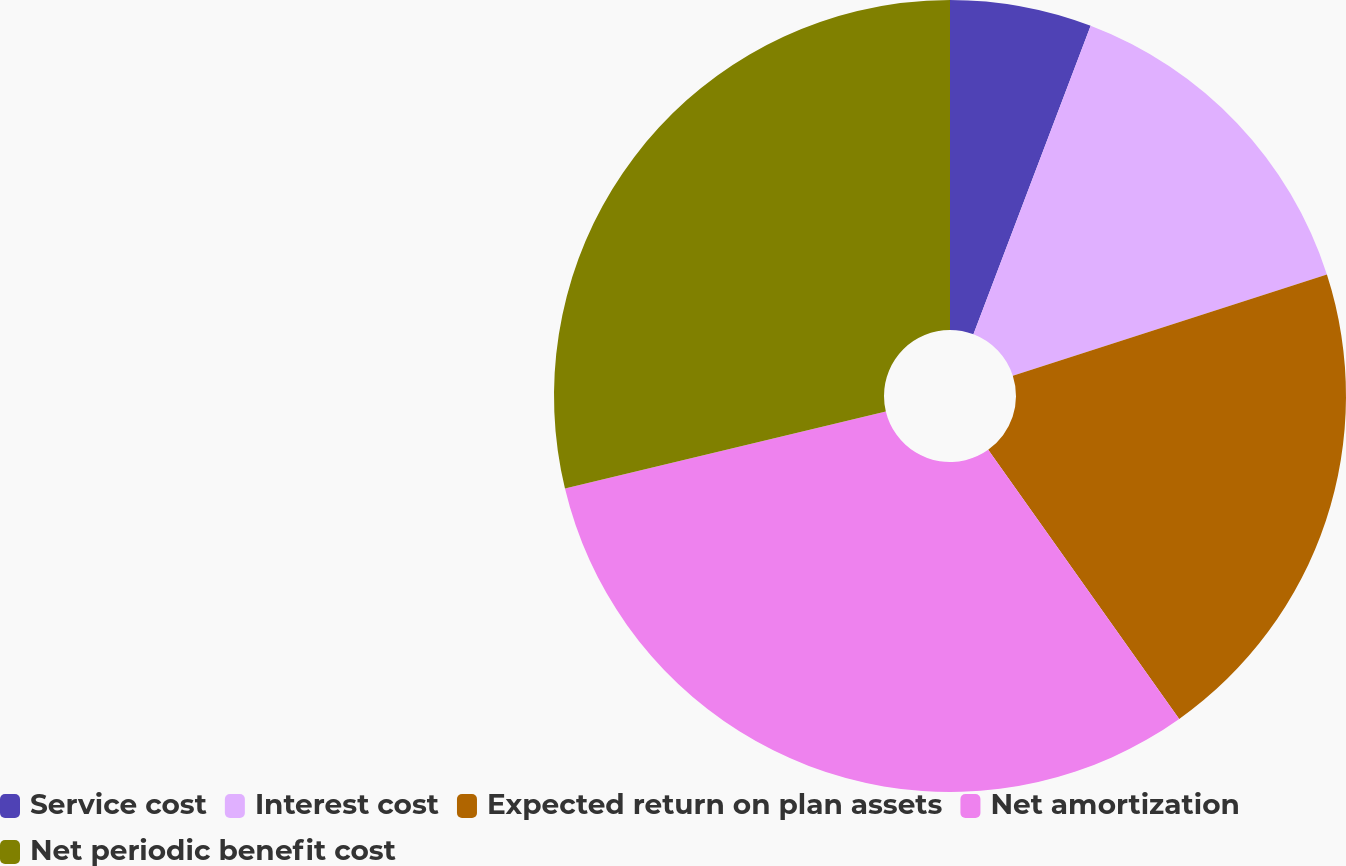Convert chart to OTSL. <chart><loc_0><loc_0><loc_500><loc_500><pie_chart><fcel>Service cost<fcel>Interest cost<fcel>Expected return on plan assets<fcel>Net amortization<fcel>Net periodic benefit cost<nl><fcel>5.78%<fcel>14.26%<fcel>20.14%<fcel>31.07%<fcel>28.76%<nl></chart> 